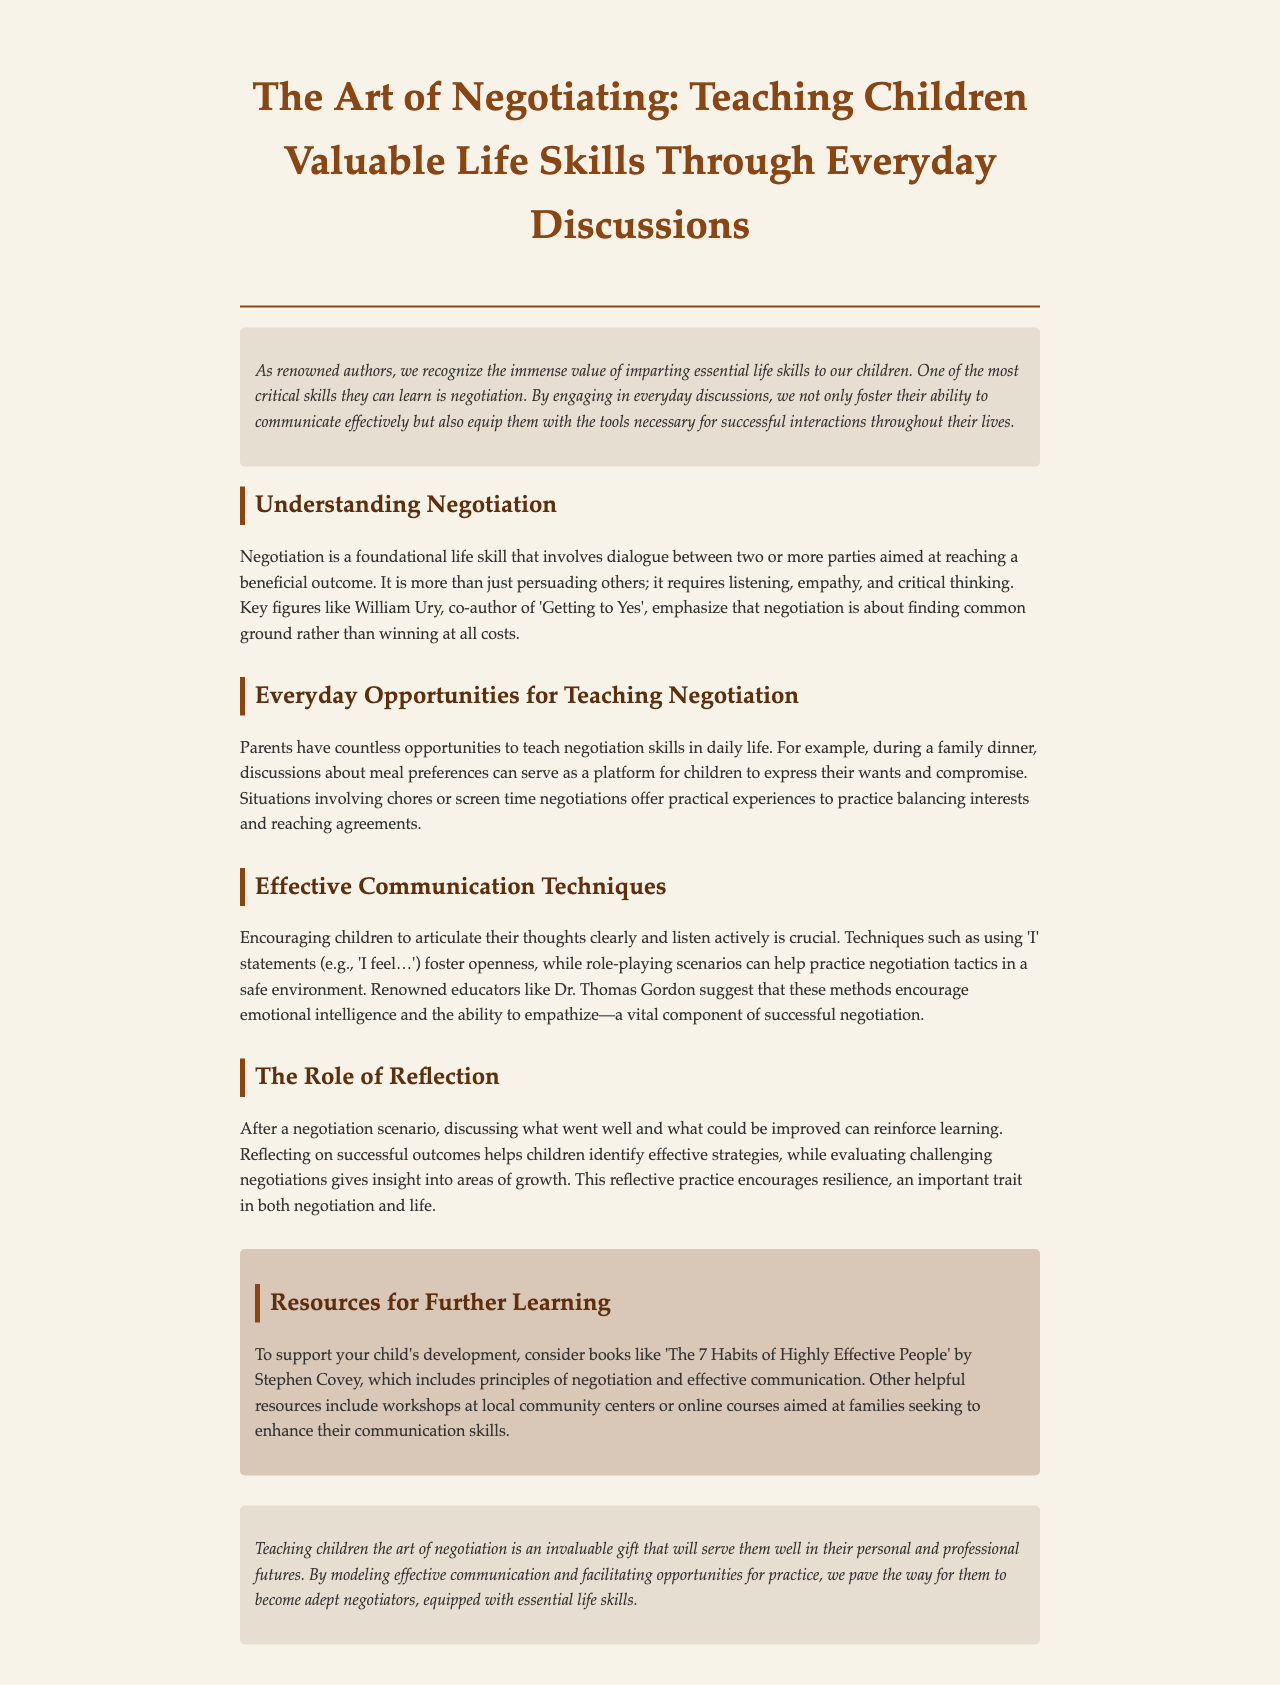What is the title of the newsletter? The title is prominently displayed in the header section of the document.
Answer: The Art of Negotiating: Teaching Children Valuable Life Skills Through Everyday Discussions Who is the co-author of 'Getting to Yes'? This information is mentioned in the section about understanding negotiation, recognizing key figures in the field.
Answer: William Ury What technique is suggested for encouraging kids to express feelings? The document specifies communication techniques that help children articulate their thoughts during negotiations.
Answer: 'I' statements What is an example of a situation where negotiation can be taught? The document provides examples of daily life situations where negotiation can occur.
Answer: Family dinner What is one resource recommended for further learning? This information can be found in the resources section, where various books and courses are suggested.
Answer: The 7 Habits of Highly Effective People What role does reflection play in negotiation? The document discusses the importance of discussing outcomes after a negotiation to reinforce learning.
Answer: Reinforcement of learning What key trait is encouraged through reflection? The document highlights the significance of certain traits that are developed through negotiation practices.
Answer: Resilience 